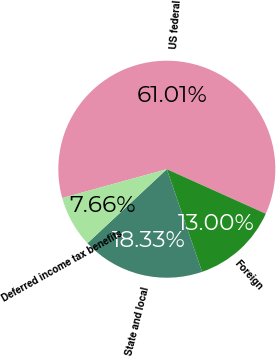<chart> <loc_0><loc_0><loc_500><loc_500><pie_chart><fcel>US federal<fcel>Foreign<fcel>State and local<fcel>Deferred income tax benefits<nl><fcel>61.01%<fcel>13.0%<fcel>18.33%<fcel>7.66%<nl></chart> 